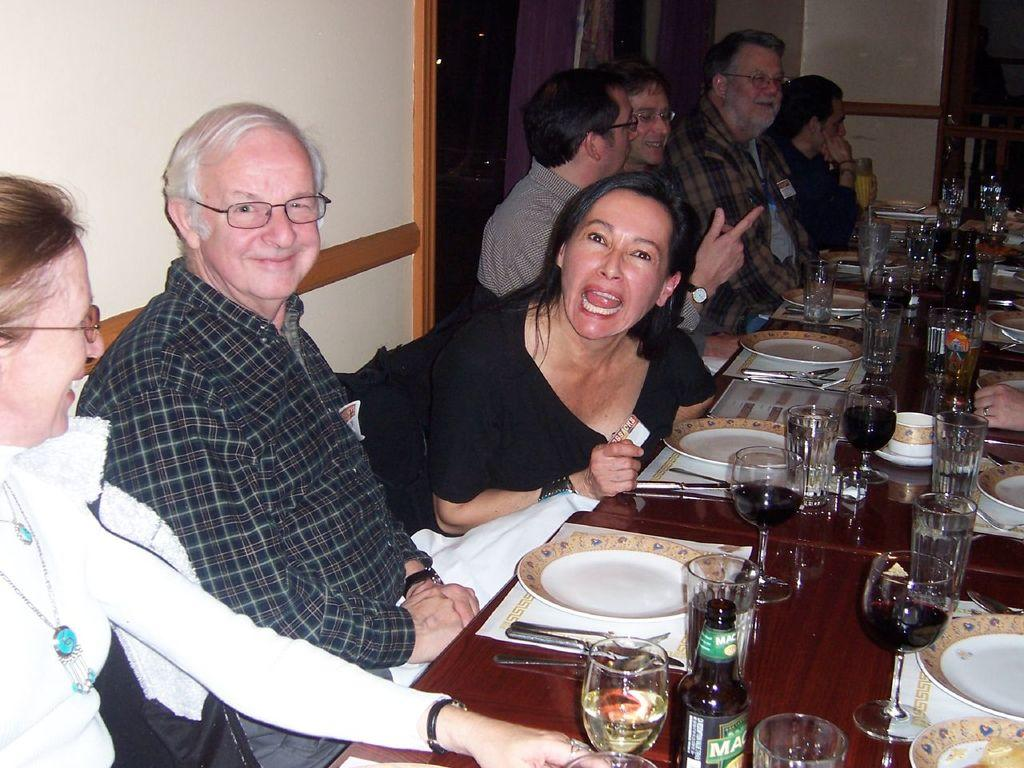What are the people in the image doing? The people in the image are sitting on chairs. What is present in the image besides the people? There is a table in the image. What can be seen on the table? There are many objects on the table. What is visible in the background of the image? There is a wall in the background of the image. What type of fruit is being served under the table in the image? There is no fruit visible in the image, and nothing is mentioned about anything being served under the table. 